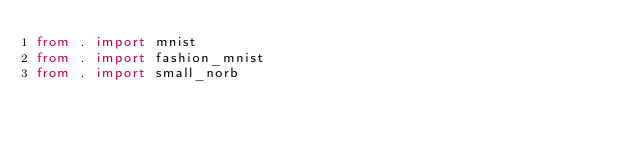<code> <loc_0><loc_0><loc_500><loc_500><_Python_>from . import mnist
from . import fashion_mnist
from . import small_norb
</code> 